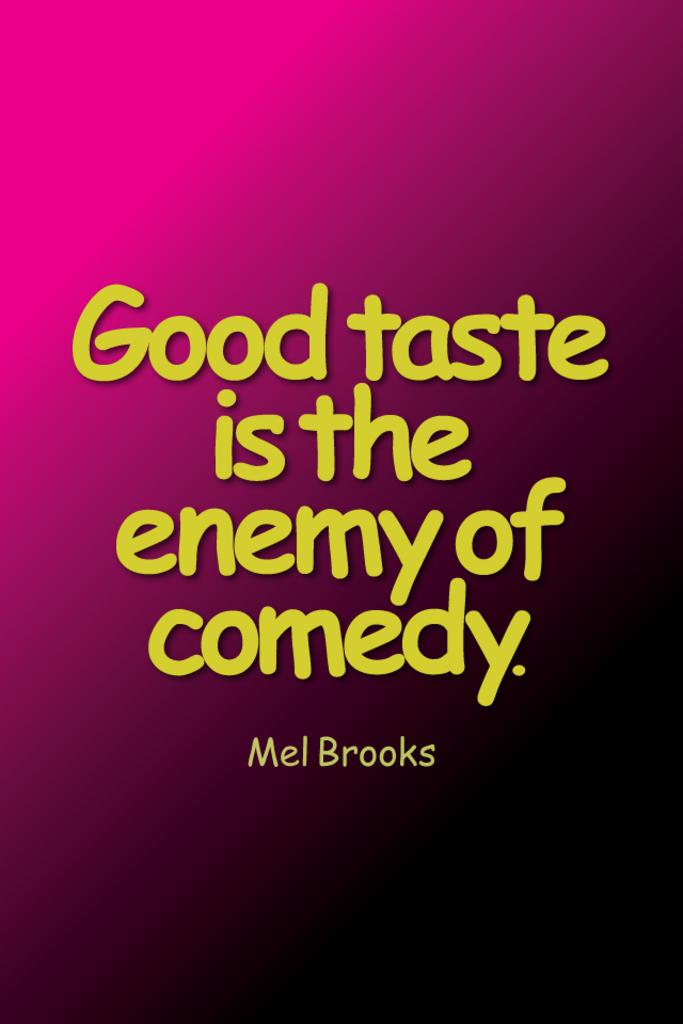<image>
Provide a brief description of the given image. A poster with a quote from Mel Brooks. 